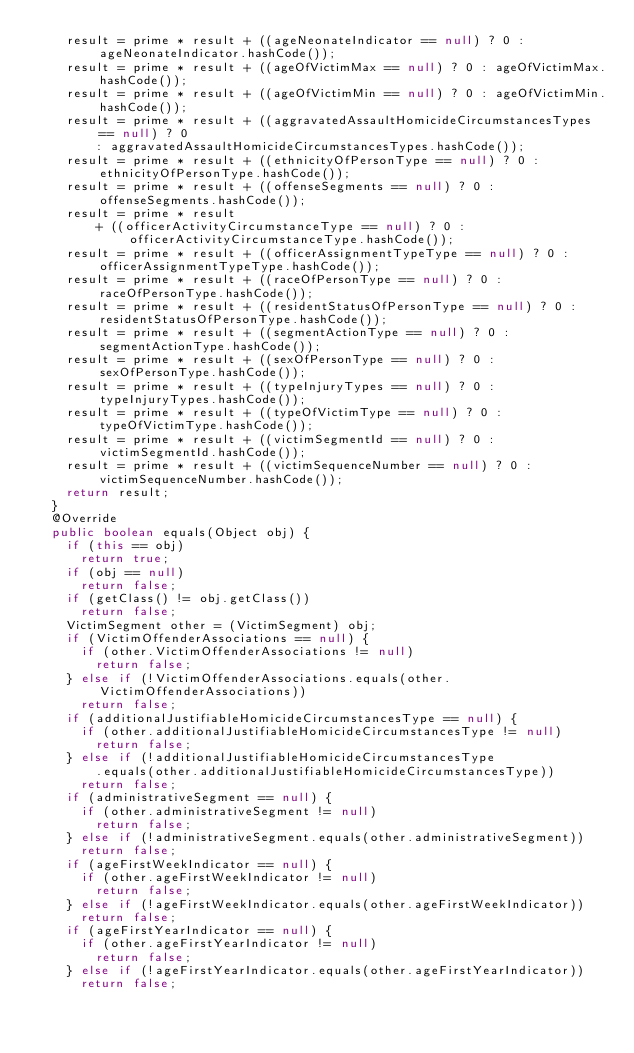Convert code to text. <code><loc_0><loc_0><loc_500><loc_500><_Java_>		result = prime * result + ((ageNeonateIndicator == null) ? 0 : ageNeonateIndicator.hashCode());
		result = prime * result + ((ageOfVictimMax == null) ? 0 : ageOfVictimMax.hashCode());
		result = prime * result + ((ageOfVictimMin == null) ? 0 : ageOfVictimMin.hashCode());
		result = prime * result + ((aggravatedAssaultHomicideCircumstancesTypes == null) ? 0
				: aggravatedAssaultHomicideCircumstancesTypes.hashCode());
		result = prime * result + ((ethnicityOfPersonType == null) ? 0 : ethnicityOfPersonType.hashCode());
		result = prime * result + ((offenseSegments == null) ? 0 : offenseSegments.hashCode());
		result = prime * result
				+ ((officerActivityCircumstanceType == null) ? 0 : officerActivityCircumstanceType.hashCode());
		result = prime * result + ((officerAssignmentTypeType == null) ? 0 : officerAssignmentTypeType.hashCode());
		result = prime * result + ((raceOfPersonType == null) ? 0 : raceOfPersonType.hashCode());
		result = prime * result + ((residentStatusOfPersonType == null) ? 0 : residentStatusOfPersonType.hashCode());
		result = prime * result + ((segmentActionType == null) ? 0 : segmentActionType.hashCode());
		result = prime * result + ((sexOfPersonType == null) ? 0 : sexOfPersonType.hashCode());
		result = prime * result + ((typeInjuryTypes == null) ? 0 : typeInjuryTypes.hashCode());
		result = prime * result + ((typeOfVictimType == null) ? 0 : typeOfVictimType.hashCode());
		result = prime * result + ((victimSegmentId == null) ? 0 : victimSegmentId.hashCode());
		result = prime * result + ((victimSequenceNumber == null) ? 0 : victimSequenceNumber.hashCode());
		return result;
	}
	@Override
	public boolean equals(Object obj) {
		if (this == obj)
			return true;
		if (obj == null)
			return false;
		if (getClass() != obj.getClass())
			return false;
		VictimSegment other = (VictimSegment) obj;
		if (VictimOffenderAssociations == null) {
			if (other.VictimOffenderAssociations != null)
				return false;
		} else if (!VictimOffenderAssociations.equals(other.VictimOffenderAssociations))
			return false;
		if (additionalJustifiableHomicideCircumstancesType == null) {
			if (other.additionalJustifiableHomicideCircumstancesType != null)
				return false;
		} else if (!additionalJustifiableHomicideCircumstancesType
				.equals(other.additionalJustifiableHomicideCircumstancesType))
			return false;
		if (administrativeSegment == null) {
			if (other.administrativeSegment != null)
				return false;
		} else if (!administrativeSegment.equals(other.administrativeSegment))
			return false;
		if (ageFirstWeekIndicator == null) {
			if (other.ageFirstWeekIndicator != null)
				return false;
		} else if (!ageFirstWeekIndicator.equals(other.ageFirstWeekIndicator))
			return false;
		if (ageFirstYearIndicator == null) {
			if (other.ageFirstYearIndicator != null)
				return false;
		} else if (!ageFirstYearIndicator.equals(other.ageFirstYearIndicator))
			return false;</code> 